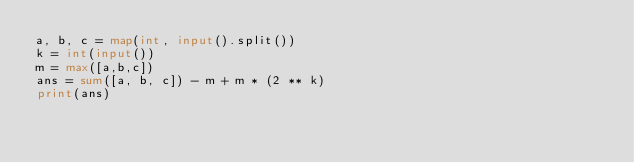Convert code to text. <code><loc_0><loc_0><loc_500><loc_500><_Python_>a, b, c = map(int, input().split())
k = int(input())
m = max([a,b,c])
ans = sum([a, b, c]) - m + m * (2 ** k)
print(ans)</code> 